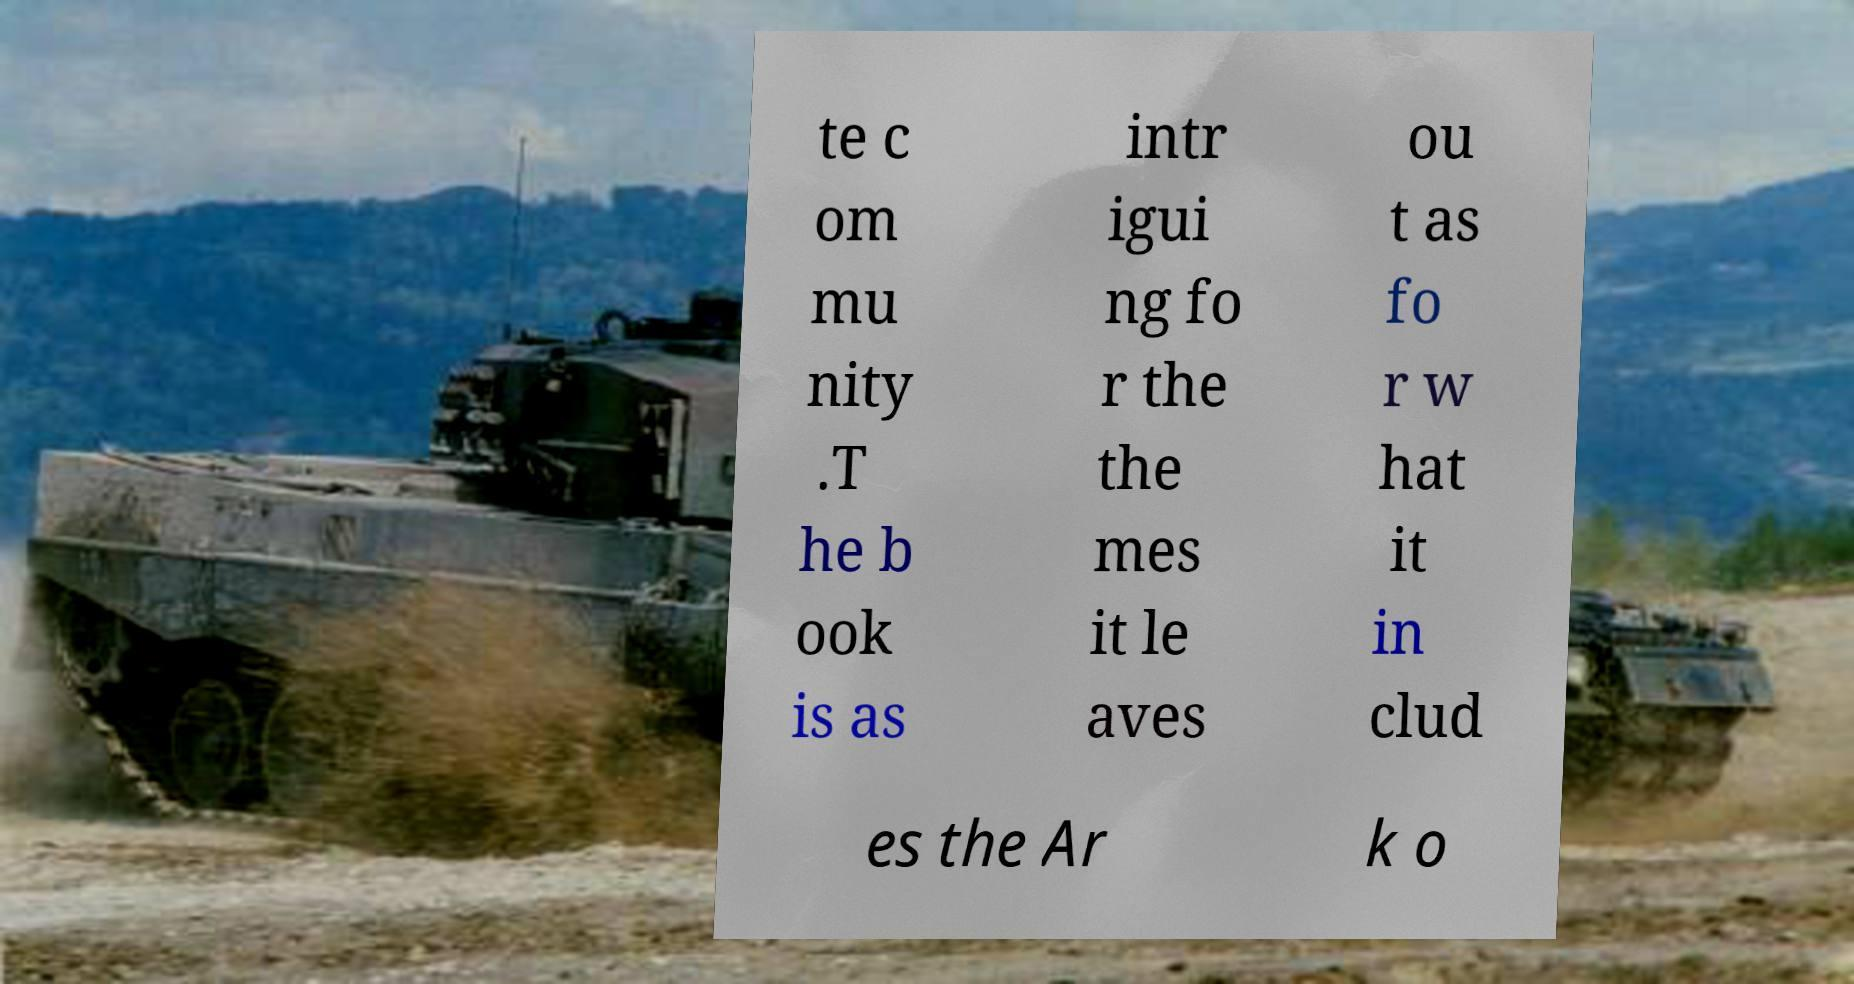Can you read and provide the text displayed in the image?This photo seems to have some interesting text. Can you extract and type it out for me? te c om mu nity .T he b ook is as intr igui ng fo r the the mes it le aves ou t as fo r w hat it in clud es the Ar k o 